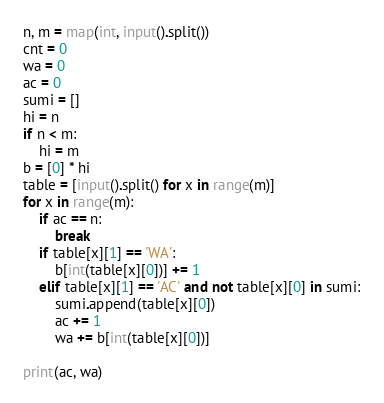Convert code to text. <code><loc_0><loc_0><loc_500><loc_500><_Python_>n, m = map(int, input().split())
cnt = 0
wa = 0
ac = 0
sumi = []
hi = n
if n < m:
    hi = m
b = [0] * hi
table = [input().split() for x in range(m)]
for x in range(m):
    if ac == n:
        break
    if table[x][1] == 'WA':
        b[int(table[x][0])] += 1
    elif table[x][1] == 'AC' and not table[x][0] in sumi:
        sumi.append(table[x][0])
        ac += 1
        wa += b[int(table[x][0])]

print(ac, wa)</code> 